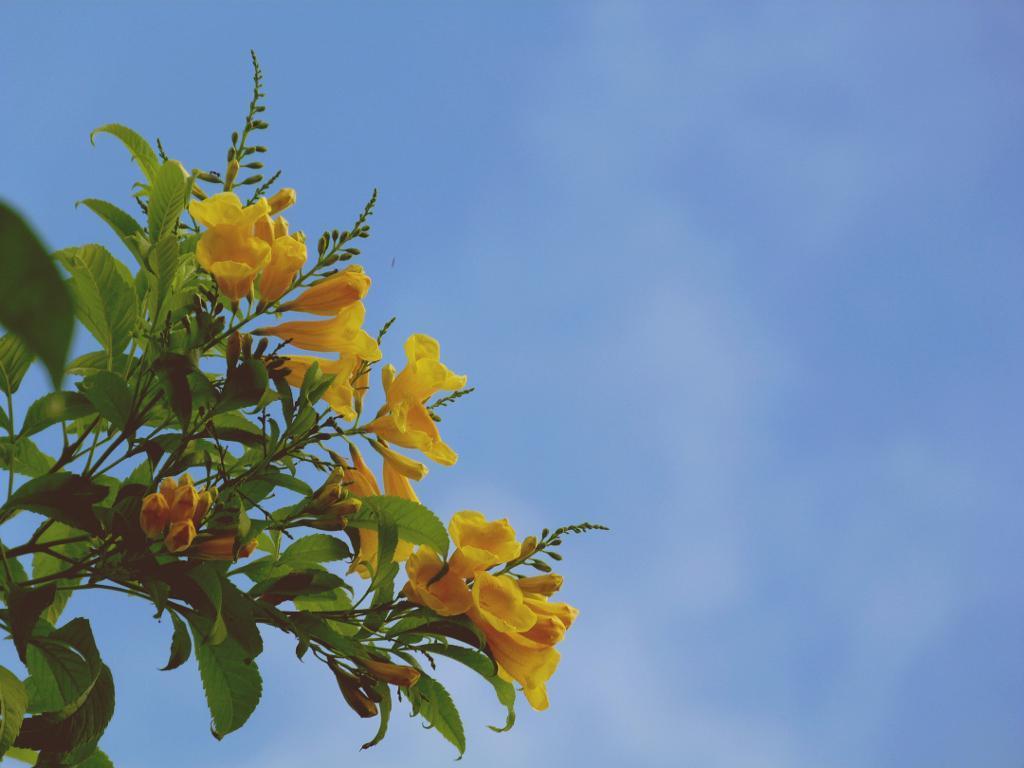In one or two sentences, can you explain what this image depicts? In the picture I can see flower plants. These flowers are yellow in color. In the background I can see the sky. 